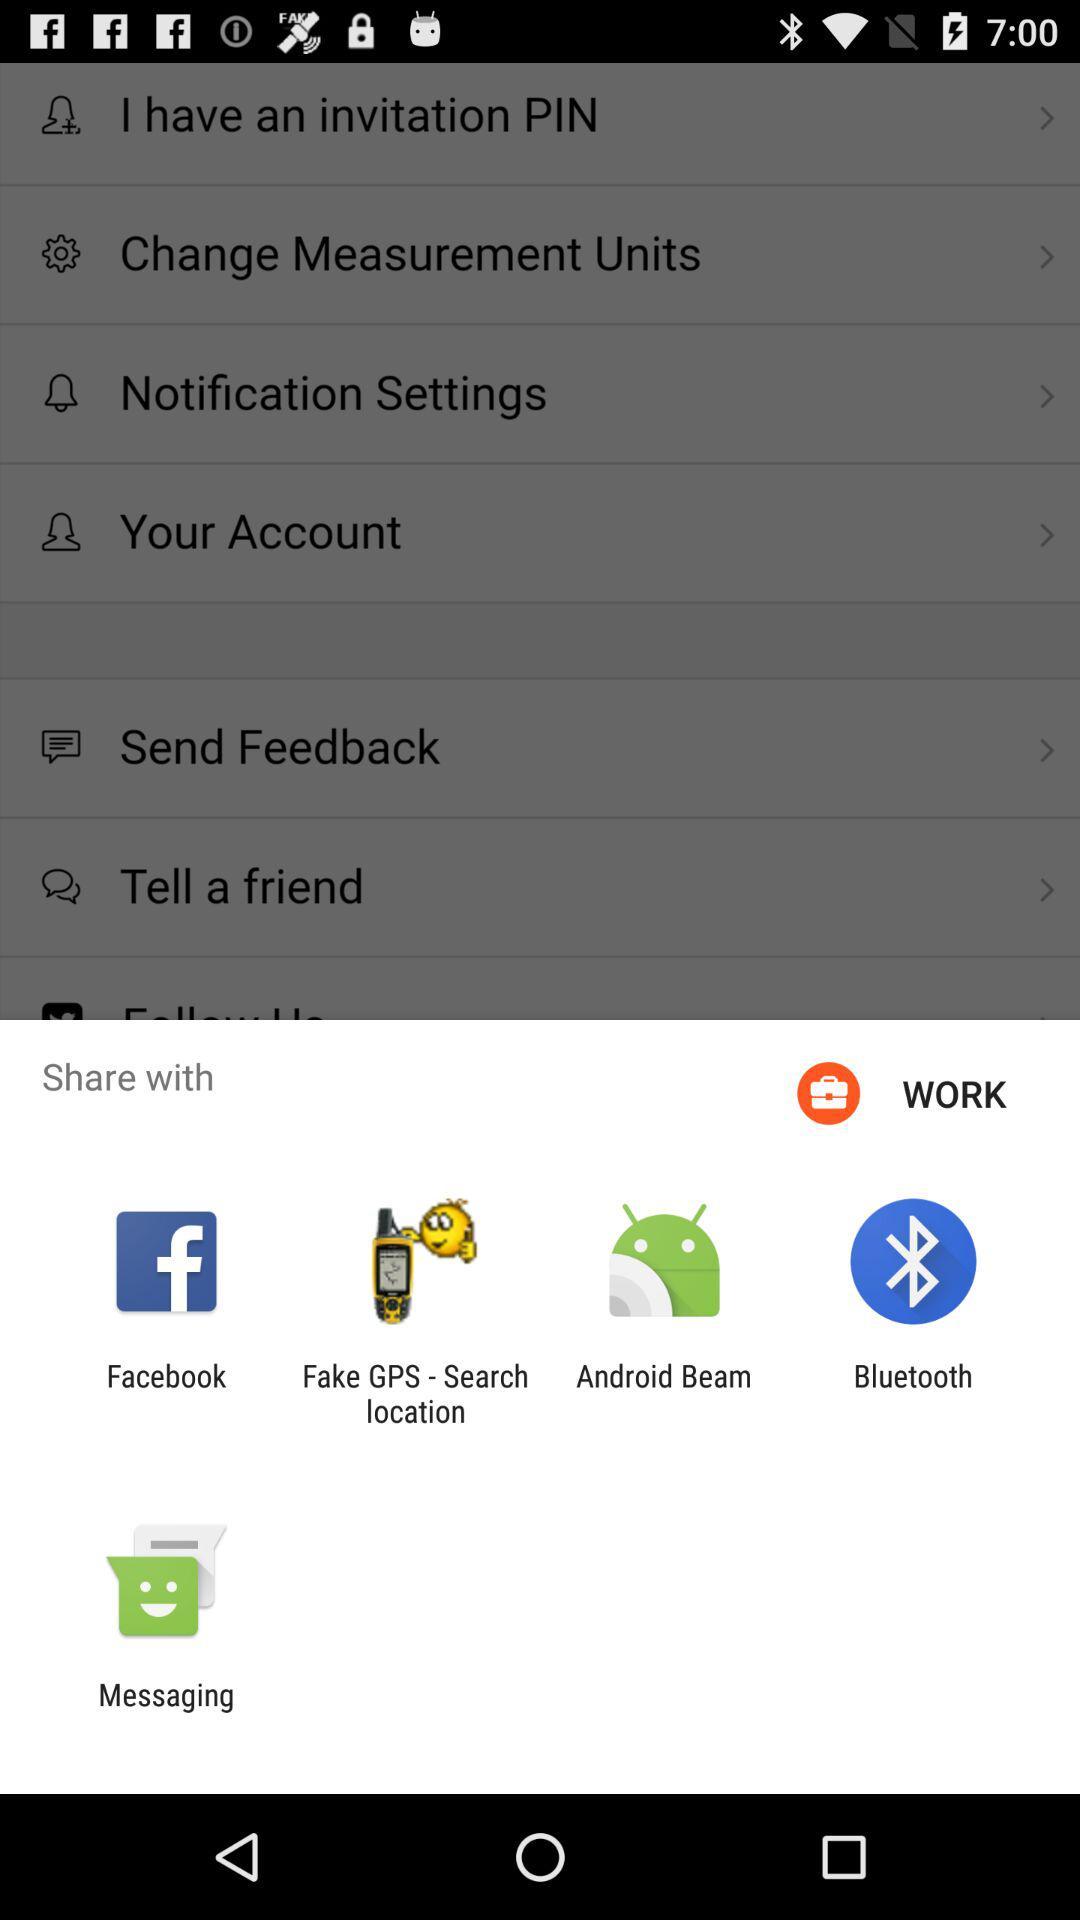Which applications can I use to share this content? The applications are "WORK", "Facebook", "Fake GPS - Search location", "Android Beam", "Bluetooth" and "Messaging". 